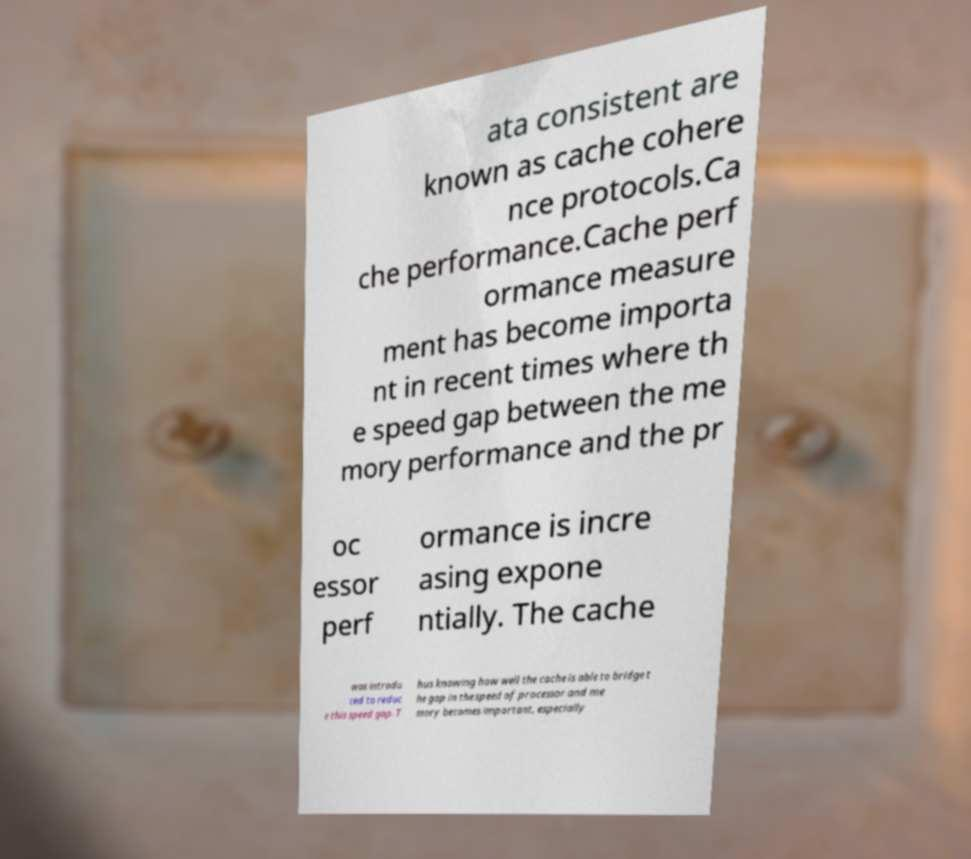For documentation purposes, I need the text within this image transcribed. Could you provide that? ata consistent are known as cache cohere nce protocols.Ca che performance.Cache perf ormance measure ment has become importa nt in recent times where th e speed gap between the me mory performance and the pr oc essor perf ormance is incre asing expone ntially. The cache was introdu ced to reduc e this speed gap. T hus knowing how well the cache is able to bridge t he gap in the speed of processor and me mory becomes important, especially 